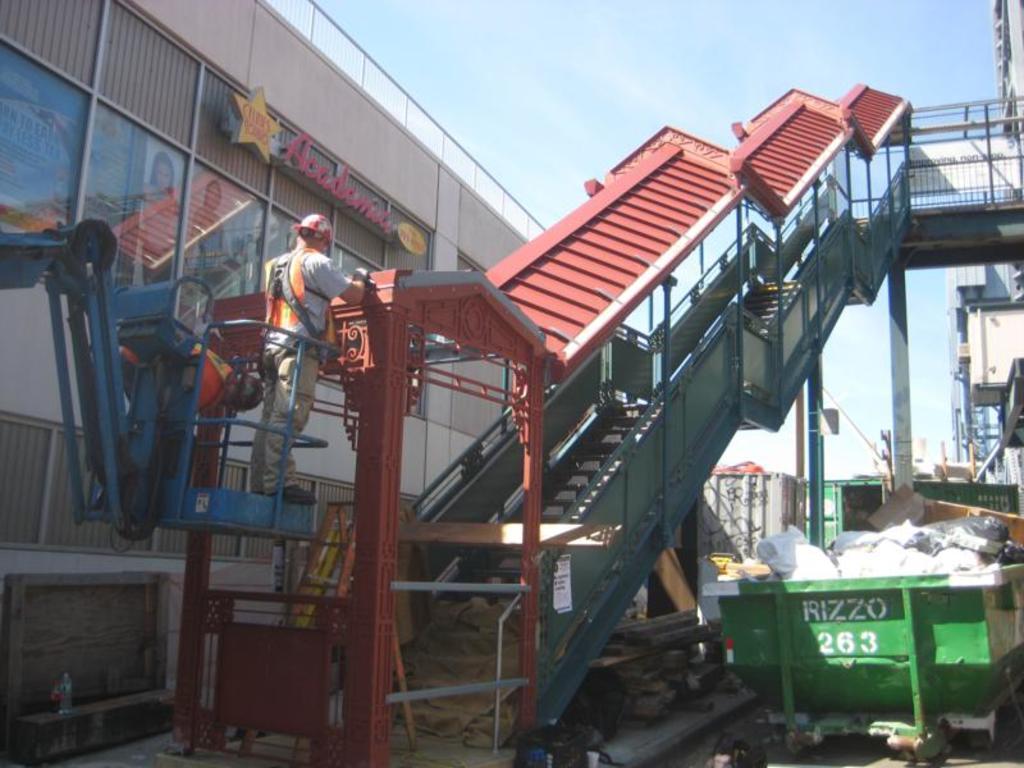Can you describe this image briefly? This is an outside view. On the left side, I can see two men are standing on the crane. In the middle of the image I can see a bridge along with the stairs. On the right side there is a dustbin on the ground and also I can see some metal objects. In a background there is a building. On the left side also I can see a building. On the top of the image I can see the sky. 